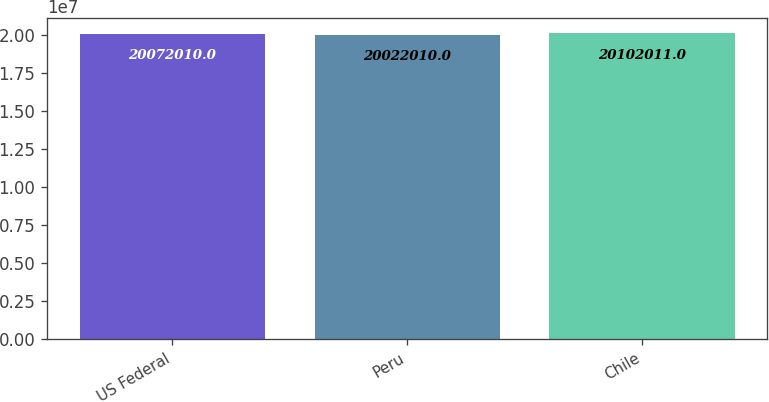Convert chart. <chart><loc_0><loc_0><loc_500><loc_500><bar_chart><fcel>US Federal<fcel>Peru<fcel>Chile<nl><fcel>2.0072e+07<fcel>2.0022e+07<fcel>2.0102e+07<nl></chart> 